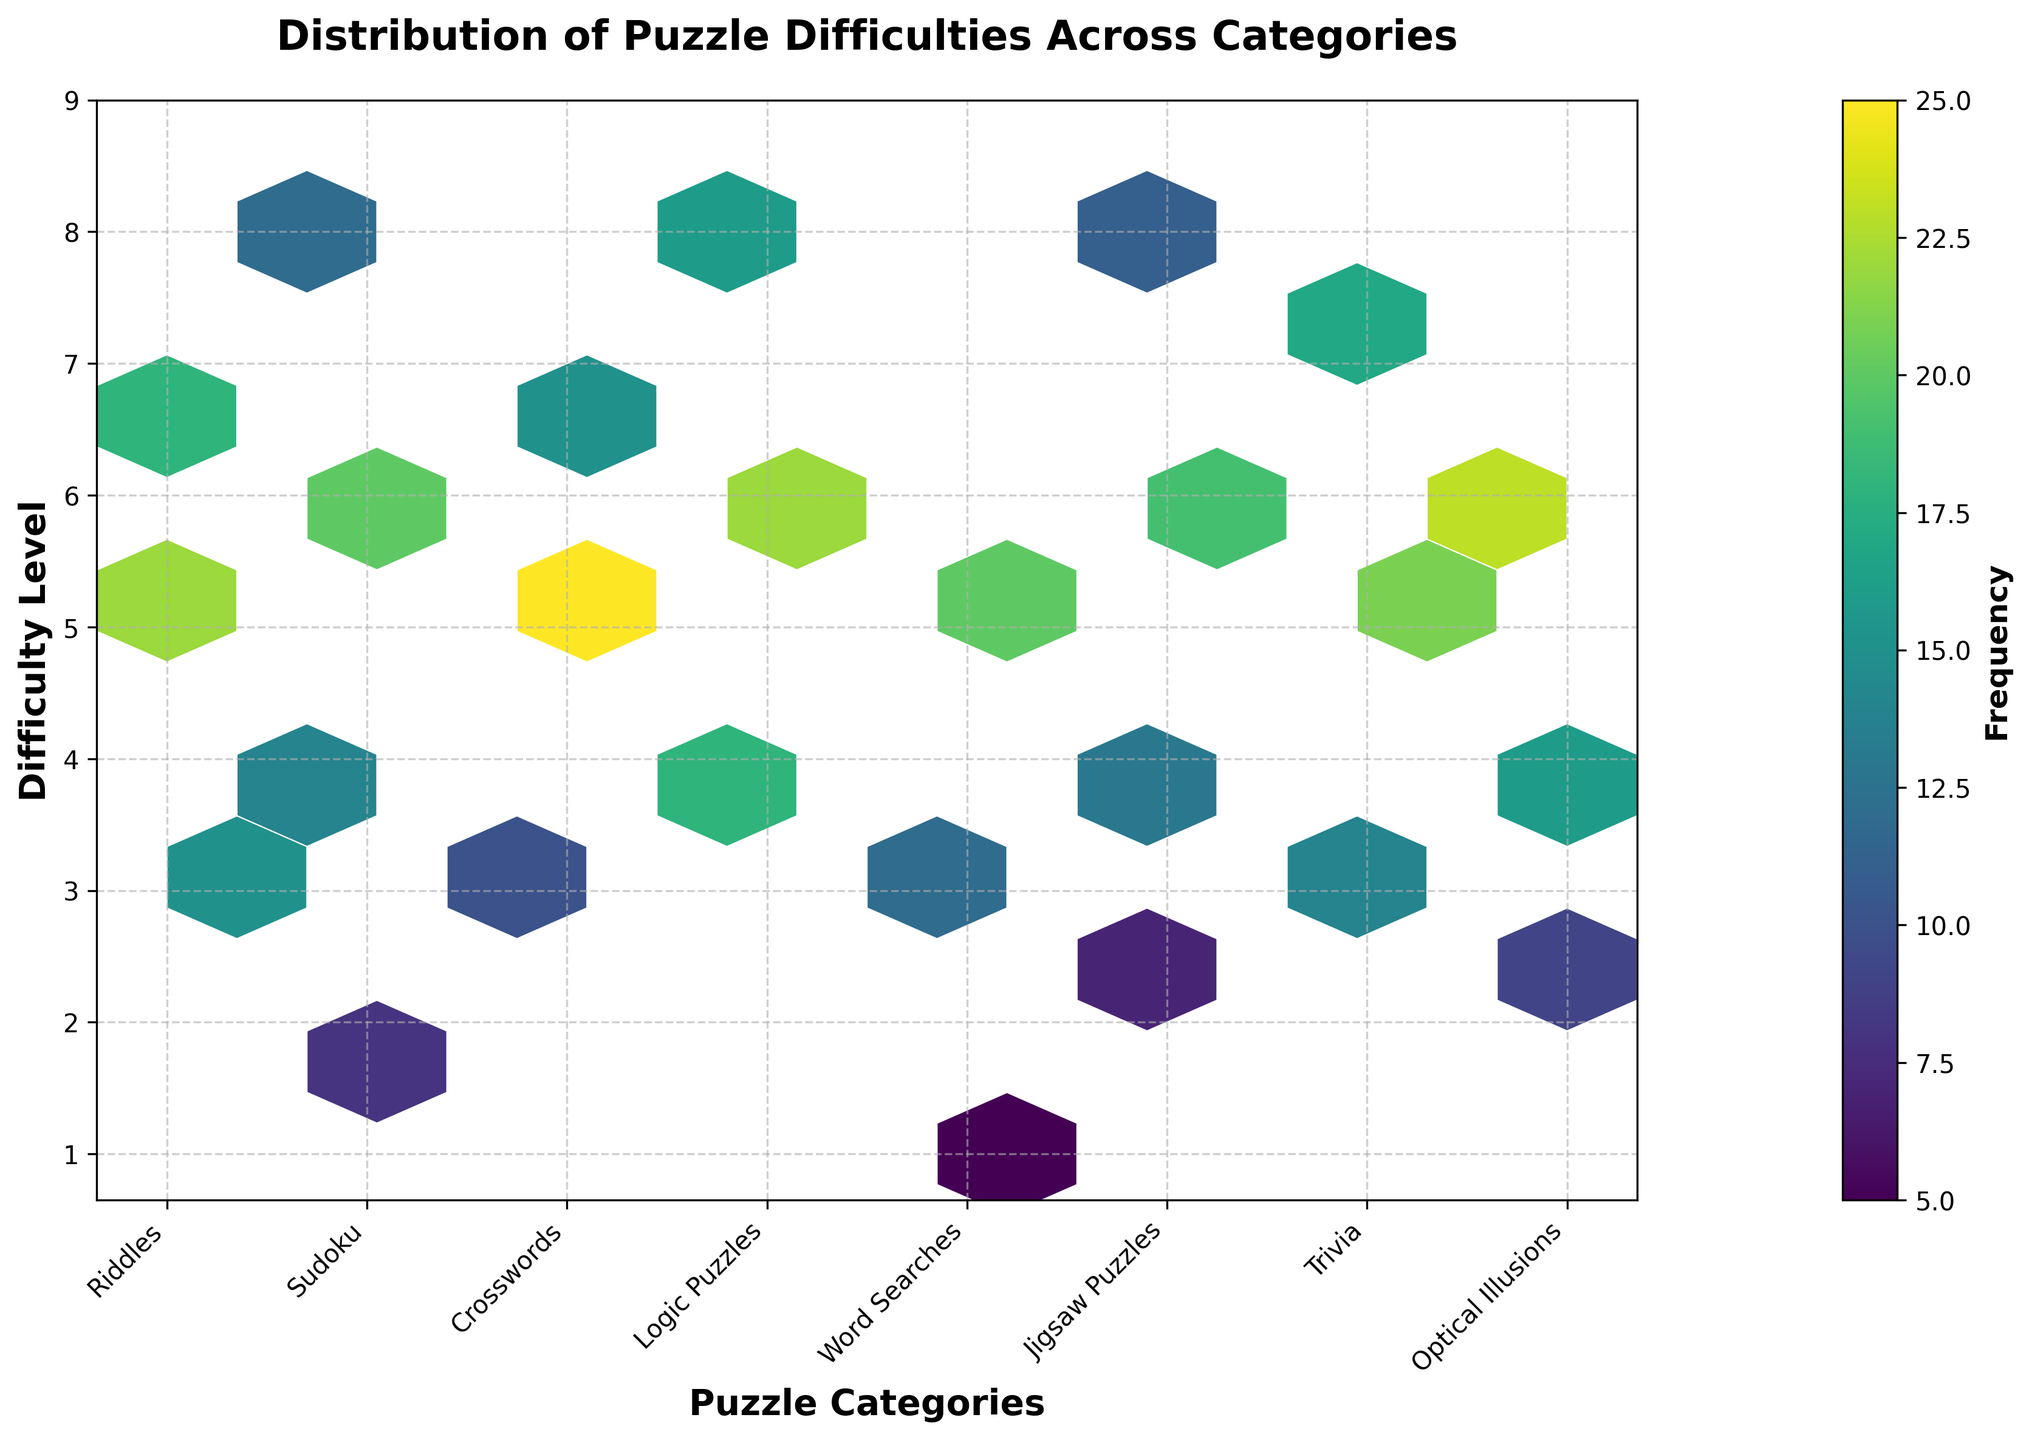What is the title of the plot? The title is displayed at the top of the plot in larger font and bold style. It indicates the subject of the hexbin plot.
Answer: Distribution of Puzzle Difficulties Across Categories What are the labels for the x-axis and y-axis? The labels are indicated below the x-axis and next to the y-axis, which help understand what each axis represents.
Answer: Puzzle Categories and Difficulty Level Which category has the highest frequency for difficulty 6? Observe the hexbin cells for difficulty level 6 and identify the category with the most intense color in the hexagons.
Answer: Optical Illusions How many distinct puzzle categories are presented in the plot? Count the number of unique tick labels on the x-axis, each representing a different puzzle category.
Answer: 7 Which puzzle category has the broadest range of difficulty levels? Check which category has hexbin cells spread across the most different difficulty levels on the y-axis.
Answer: Sudoku For the category 'Word Searches', what is the average difficulty level based on the hexbin plot? Identify the difficulty levels for 'Word Searches' and calculate the average: (1*5 + 3*12 + 5*20) / (5+12+20) = (5 + 36 + 100) / 37 ≈ 3.70
Answer: 3.70 What is the combined frequency of Riddles and Crosswords for difficulty level 5? Find the hexbin cells corresponding to difficulty 5 for both 'Riddles' and 'Crosswords' and sum their frequencies: 22 (Riddles) + 25 (Crosswords) = 47
Answer: 47 Which difficulty level has the highest total frequency across all puzzle categories? Sum the frequencies of all categories for each difficulty level and identify the level with the highest sum.
Answer: 6 Which parameter is represented by the color intensity in the hexbin cells? The color intensity in the hexbin cells is described by the color bar on the right side of the plot. It shows how a value, typically frequency, changes with color shades.
Answer: Frequency 